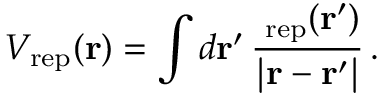<formula> <loc_0><loc_0><loc_500><loc_500>V _ { r e p } ( { r } ) = \int d r ^ { \prime } \, \frac { \rho _ { r e p } ( r ^ { \prime } ) } { | r - r ^ { \prime } | } \, .</formula> 